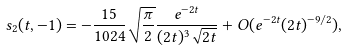<formula> <loc_0><loc_0><loc_500><loc_500>s _ { 2 } ( t , - 1 ) = - \frac { 1 5 } { 1 0 2 4 } \sqrt { \frac { \pi } { 2 } } \frac { e ^ { - 2 t } } { ( 2 t ) ^ { 3 } \sqrt { 2 t } } + { O } ( e ^ { - 2 t } ( 2 t ) ^ { - 9 / 2 } ) ,</formula> 